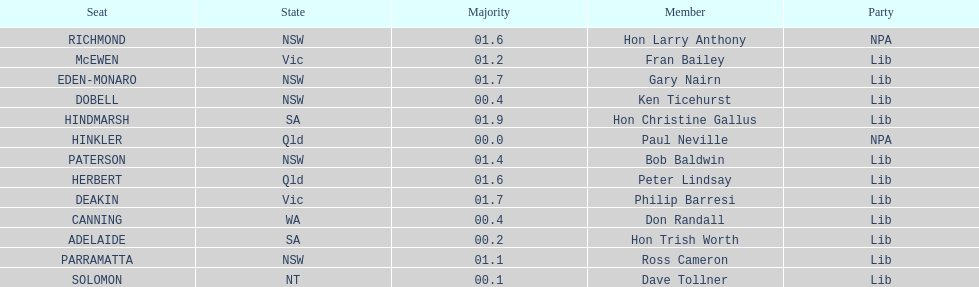What is the overall number of seats? 13. 